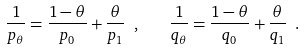<formula> <loc_0><loc_0><loc_500><loc_500>\frac { 1 } { p _ { \theta } } = \frac { 1 - \theta } { p _ { 0 } } + \frac { \theta } { p _ { 1 } } \ , \quad \frac { 1 } { q _ { \theta } } = \frac { 1 - \theta } { q _ { 0 } } + \frac { \theta } { q _ { 1 } } \ .</formula> 